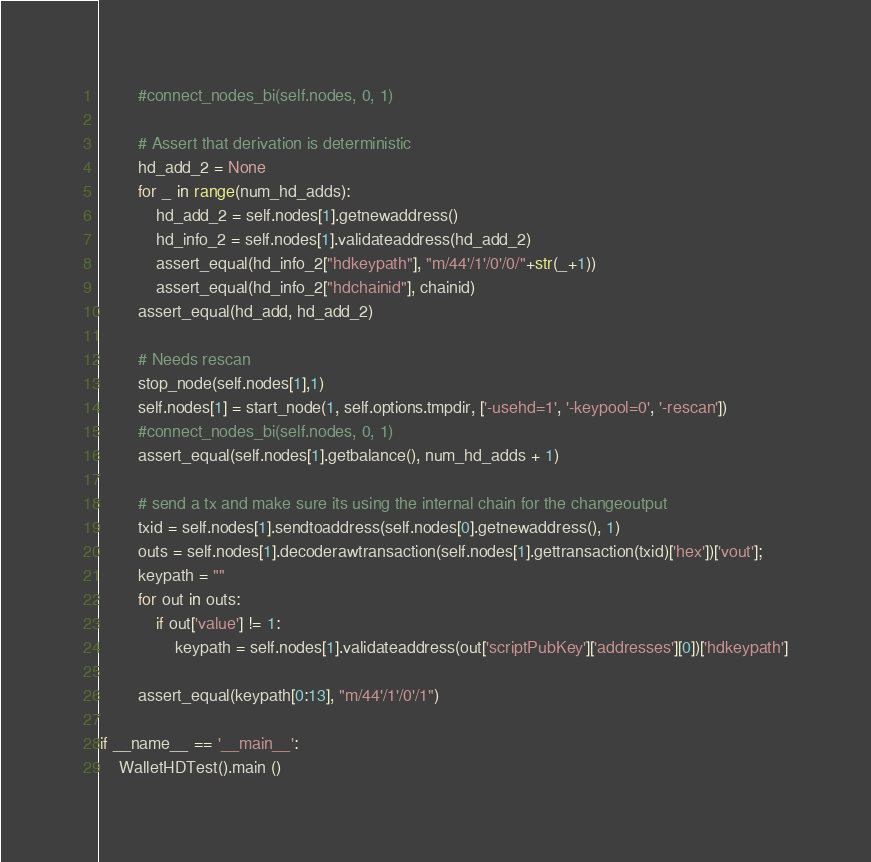Convert code to text. <code><loc_0><loc_0><loc_500><loc_500><_Python_>        #connect_nodes_bi(self.nodes, 0, 1)

        # Assert that derivation is deterministic
        hd_add_2 = None
        for _ in range(num_hd_adds):
            hd_add_2 = self.nodes[1].getnewaddress()
            hd_info_2 = self.nodes[1].validateaddress(hd_add_2)
            assert_equal(hd_info_2["hdkeypath"], "m/44'/1'/0'/0/"+str(_+1))
            assert_equal(hd_info_2["hdchainid"], chainid)
        assert_equal(hd_add, hd_add_2)

        # Needs rescan
        stop_node(self.nodes[1],1)
        self.nodes[1] = start_node(1, self.options.tmpdir, ['-usehd=1', '-keypool=0', '-rescan'])
        #connect_nodes_bi(self.nodes, 0, 1)
        assert_equal(self.nodes[1].getbalance(), num_hd_adds + 1)

        # send a tx and make sure its using the internal chain for the changeoutput
        txid = self.nodes[1].sendtoaddress(self.nodes[0].getnewaddress(), 1)
        outs = self.nodes[1].decoderawtransaction(self.nodes[1].gettransaction(txid)['hex'])['vout'];
        keypath = ""
        for out in outs:
            if out['value'] != 1:
                keypath = self.nodes[1].validateaddress(out['scriptPubKey']['addresses'][0])['hdkeypath']

        assert_equal(keypath[0:13], "m/44'/1'/0'/1")

if __name__ == '__main__':
    WalletHDTest().main ()
</code> 